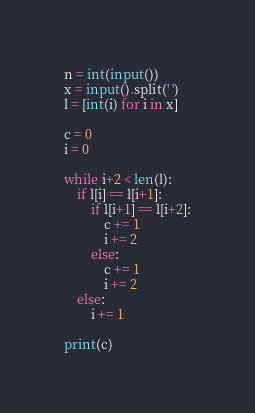<code> <loc_0><loc_0><loc_500><loc_500><_Python_>n = int(input())
x = input().split(' ')
l = [int(i) for i in x]

c = 0
i = 0

while i+2 < len(l):
    if l[i] == l[i+1]:
        if l[i+1] == l[i+2]:
            c += 1
            i += 2
        else:
            c += 1
            i += 2
    else:
        i += 1

print(c)
</code> 